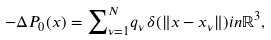<formula> <loc_0><loc_0><loc_500><loc_500>- \Delta P _ { 0 } ( x ) = { \sum } _ { \nu = 1 } ^ { N } { q _ { \nu } } \, \delta ( { \| x - x _ { \nu } \| } ) i n \mathbb { R } ^ { 3 } ,</formula> 